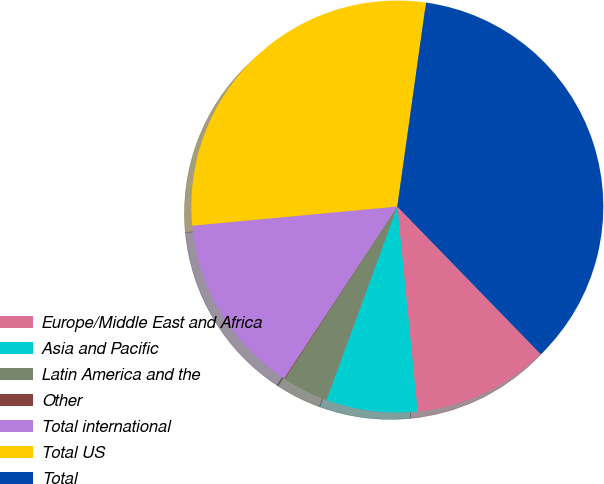Convert chart. <chart><loc_0><loc_0><loc_500><loc_500><pie_chart><fcel>Europe/Middle East and Africa<fcel>Asia and Pacific<fcel>Latin America and the<fcel>Other<fcel>Total international<fcel>Total US<fcel>Total<nl><fcel>10.7%<fcel>7.16%<fcel>3.62%<fcel>0.07%<fcel>14.24%<fcel>28.71%<fcel>35.5%<nl></chart> 